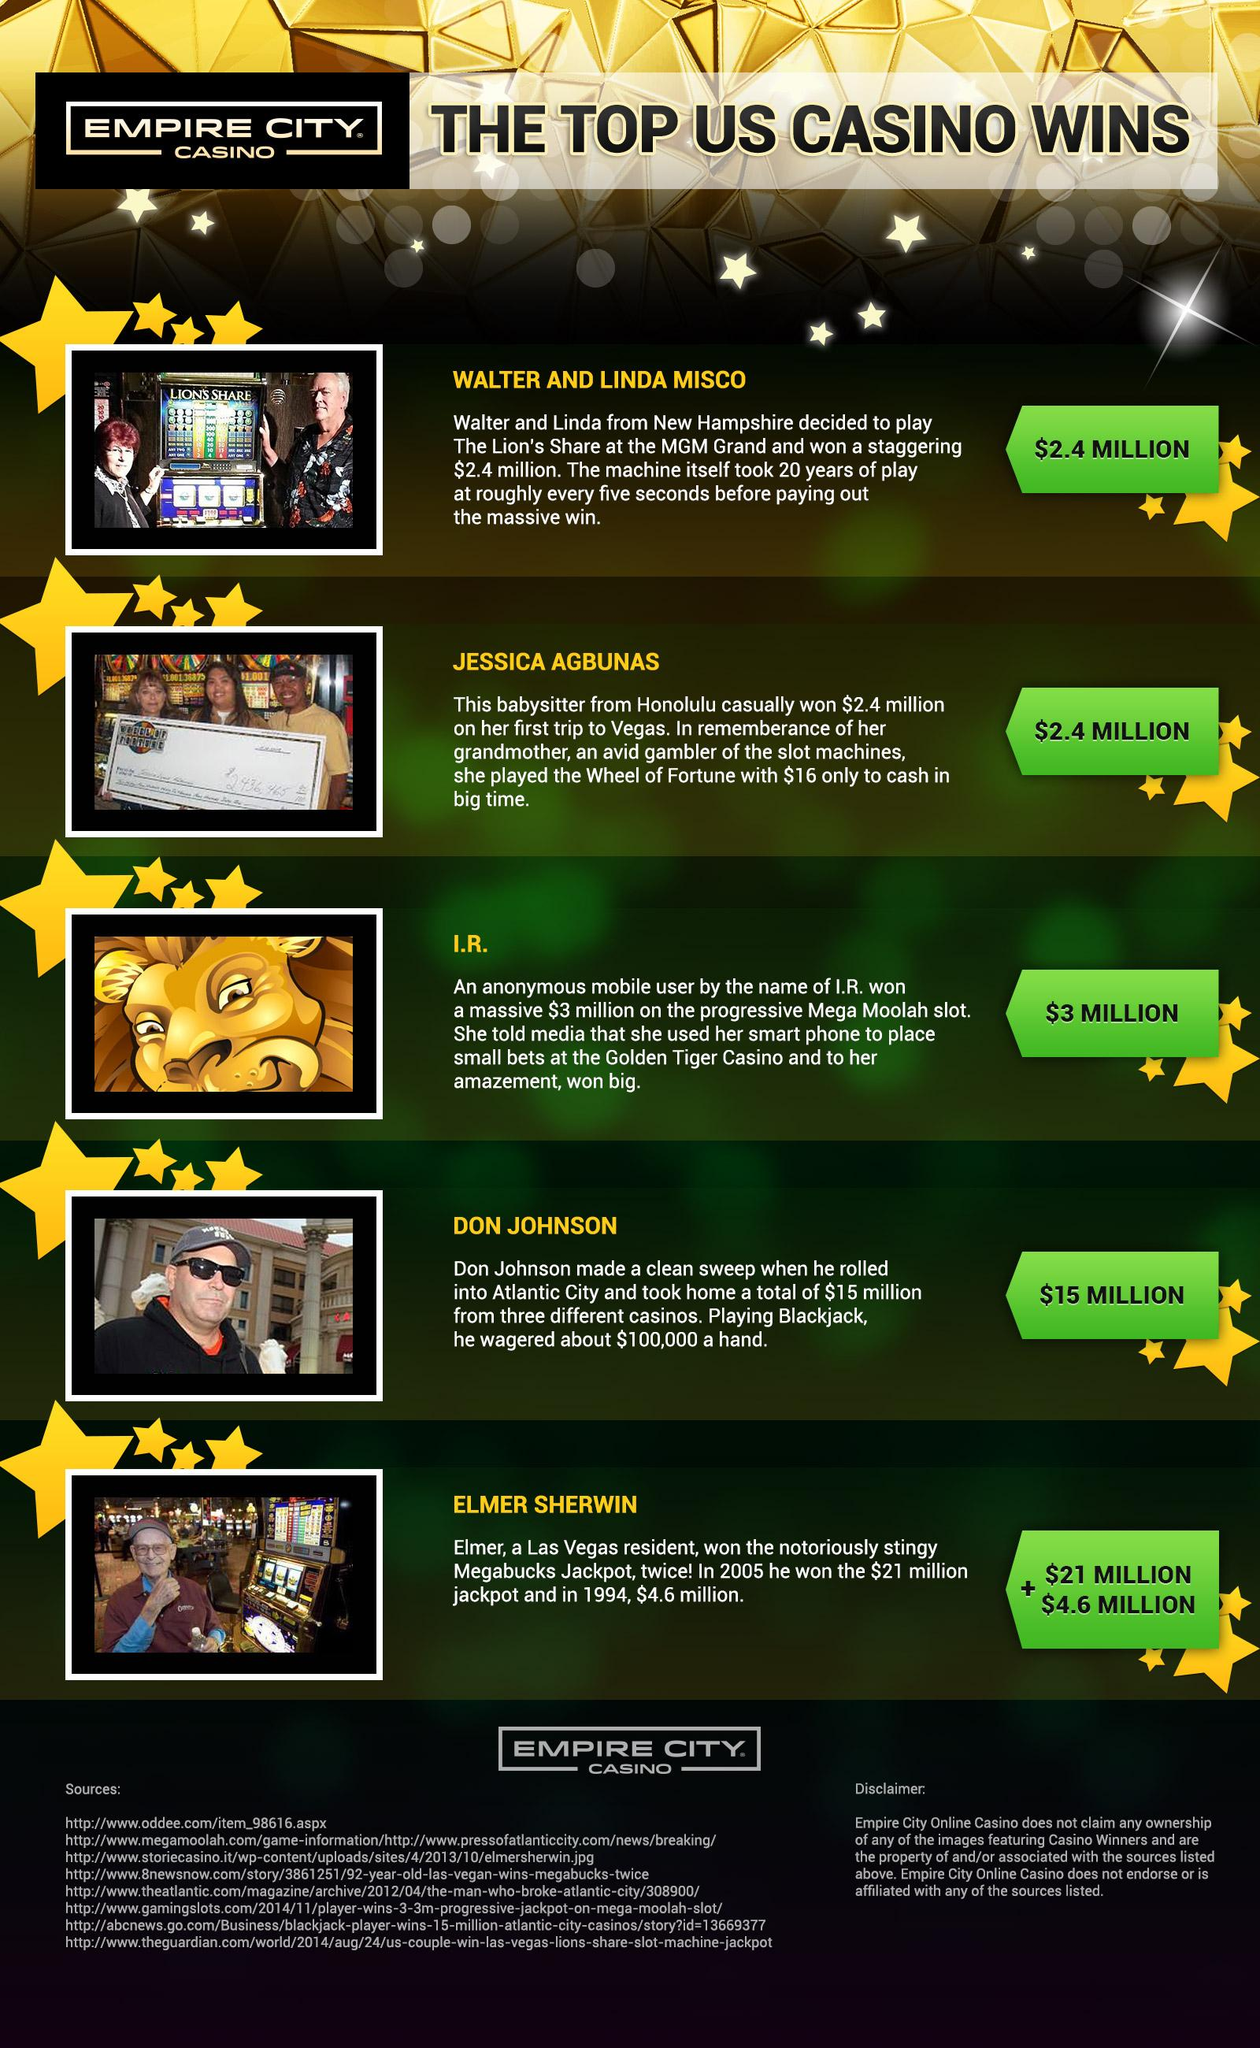Outline some significant characteristics in this image. Walter and Linda Miscowon the grand prize of $2.4 million. Jessica Agbunas had $16 with her. Elmer Sherwin won a total of 25.6 million dollars from Empire City Casino. 